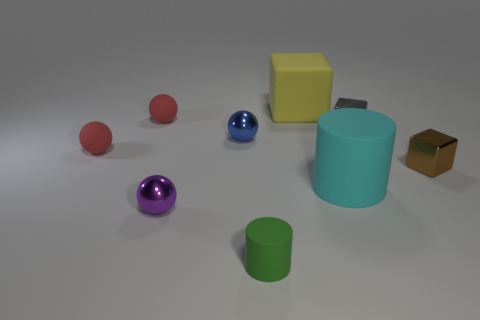What is the shape of the big cyan matte object?
Your response must be concise. Cylinder. Does the tiny red thing that is behind the blue sphere have the same material as the small brown cube?
Give a very brief answer. No. Is there a small metallic cube of the same color as the large block?
Provide a succinct answer. No. Do the large matte thing behind the large matte cylinder and the big thing in front of the tiny brown shiny thing have the same shape?
Provide a short and direct response. No. Is there a tiny green object made of the same material as the purple thing?
Make the answer very short. No. How many gray things are metal objects or tiny metal blocks?
Provide a succinct answer. 1. What is the size of the object that is in front of the small brown metallic thing and behind the purple thing?
Give a very brief answer. Large. Are there more small purple objects that are behind the cyan cylinder than small blue metal cylinders?
Give a very brief answer. No. How many cubes are either tiny gray shiny objects or red rubber things?
Provide a short and direct response. 1. What is the shape of the thing that is right of the blue ball and behind the gray metal object?
Keep it short and to the point. Cube. 